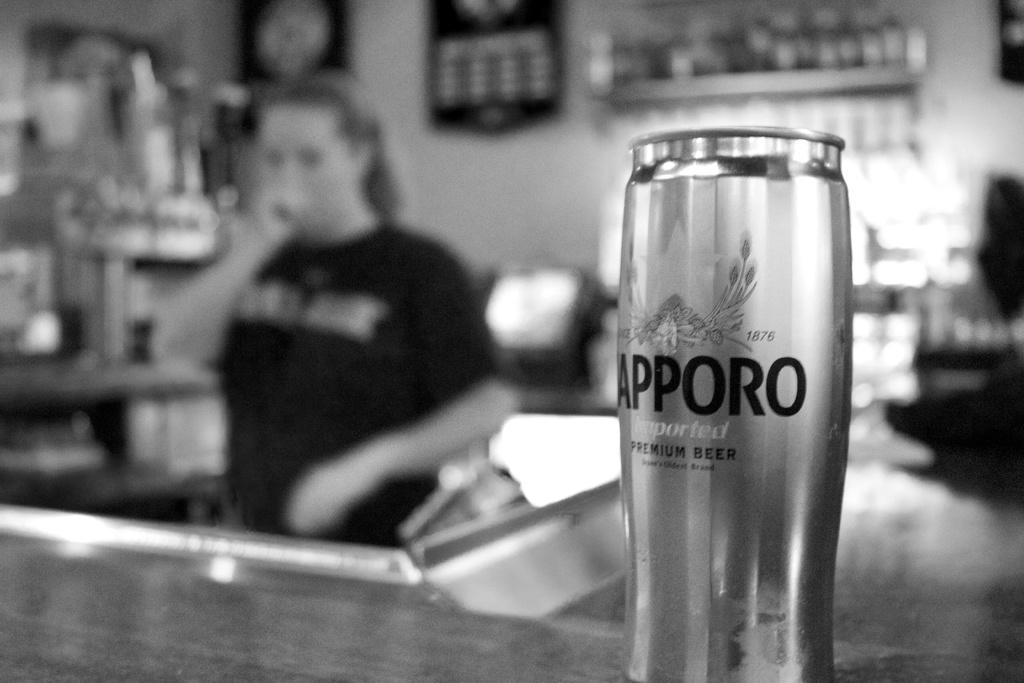What object is present in the image that is related to a beverage? There is a beer can in the image. Can you describe the person in the image? There is a person standing in the image. How would you describe the background of the image? The background of the image is blurred. What type of creature can be seen flying in the image? There is no creature visible in the image, and the user is not mentioned in the provided facts. 